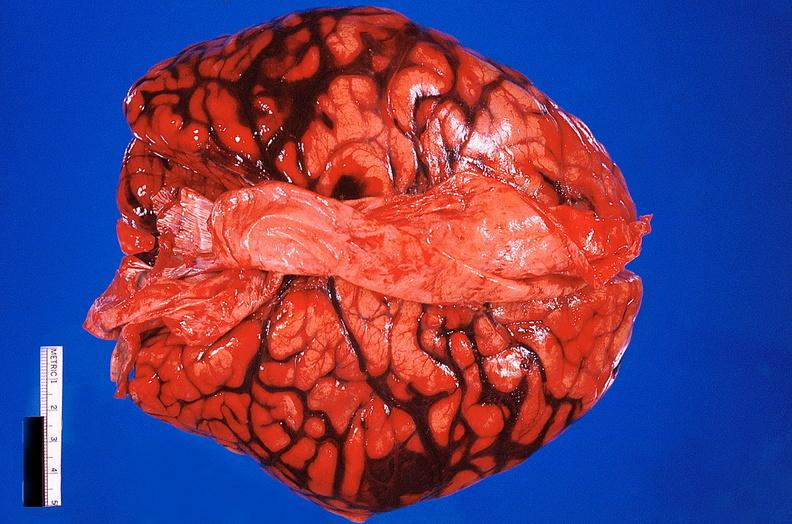does fibrous meningioma show brain, subarachanoid hemorrhage due to ruptured aneurysm?
Answer the question using a single word or phrase. No 